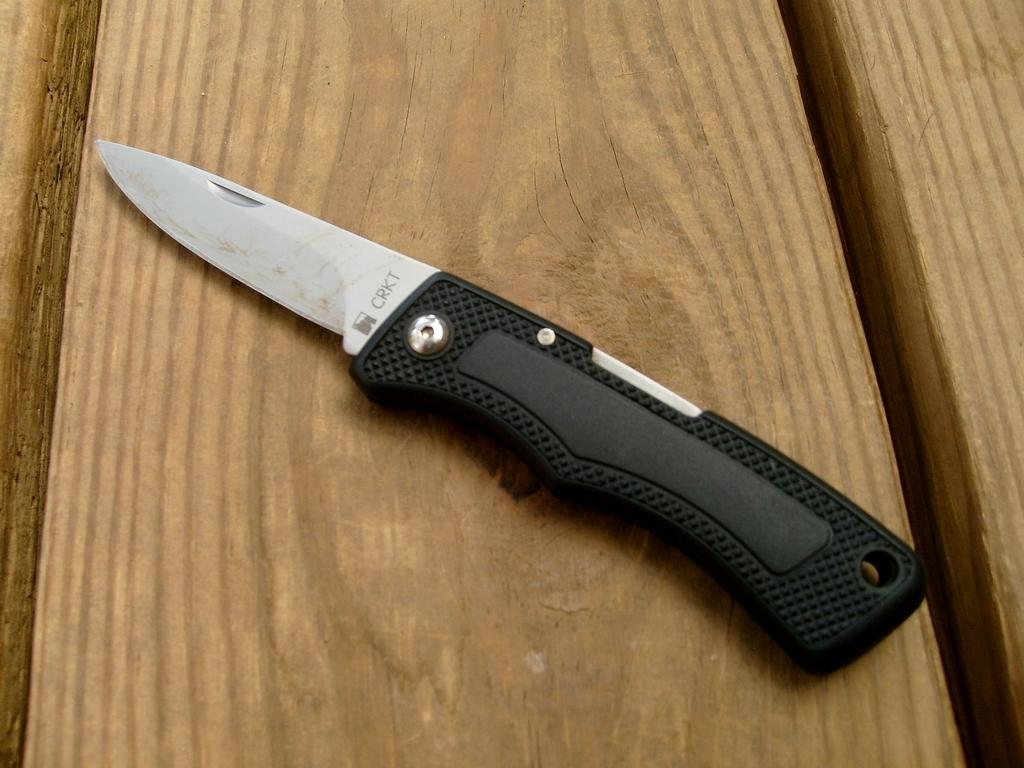What object is present in the image that can be used for cutting? There is a knife in the image. What is the color of the surface on which the knife is placed? The knife is on a brown-colored surface. What type of locket is hanging from the knife in the image? There is no locket present in the image; the knife is on a brown-colored surface. 